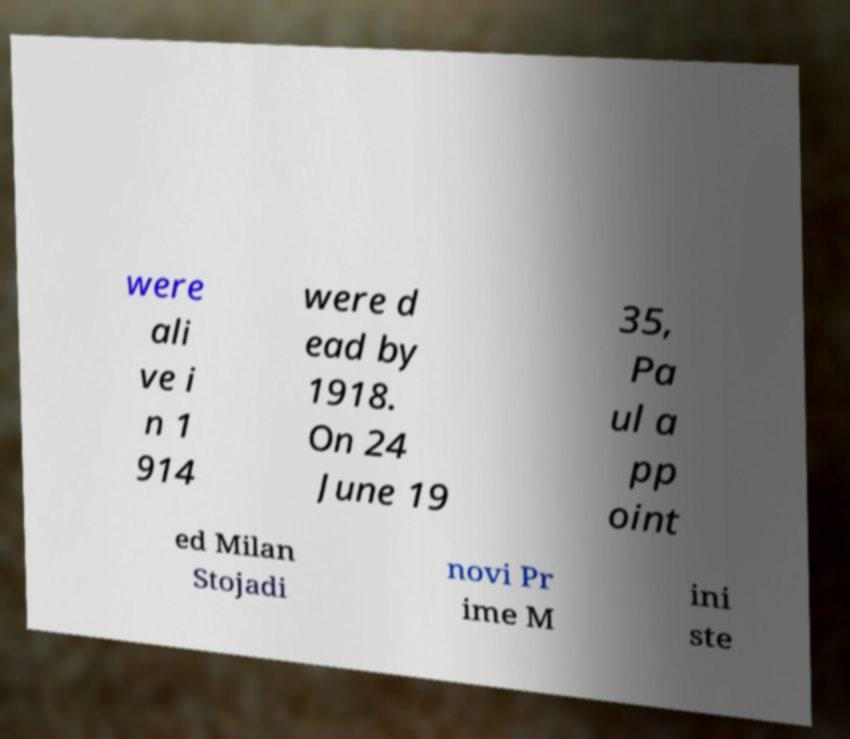I need the written content from this picture converted into text. Can you do that? were ali ve i n 1 914 were d ead by 1918. On 24 June 19 35, Pa ul a pp oint ed Milan Stojadi novi Pr ime M ini ste 